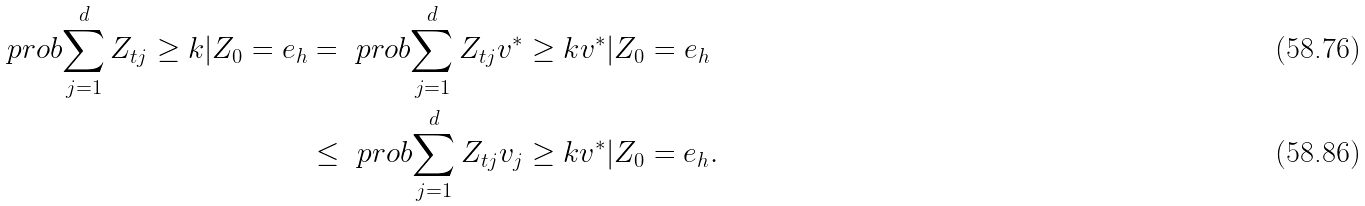<formula> <loc_0><loc_0><loc_500><loc_500>\ p r o b { \sum _ { j = 1 } ^ { d } Z _ { t j } \geq k | Z _ { 0 } = e _ { h } } & = \ p r o b { \sum _ { j = 1 } ^ { d } Z _ { t j } v ^ { * } \geq k v ^ { * } | Z _ { 0 } = e _ { h } } \\ & \leq \ p r o b { \sum _ { j = 1 } ^ { d } Z _ { t j } v _ { j } \geq k v ^ { * } | Z _ { 0 } = e _ { h } } .</formula> 